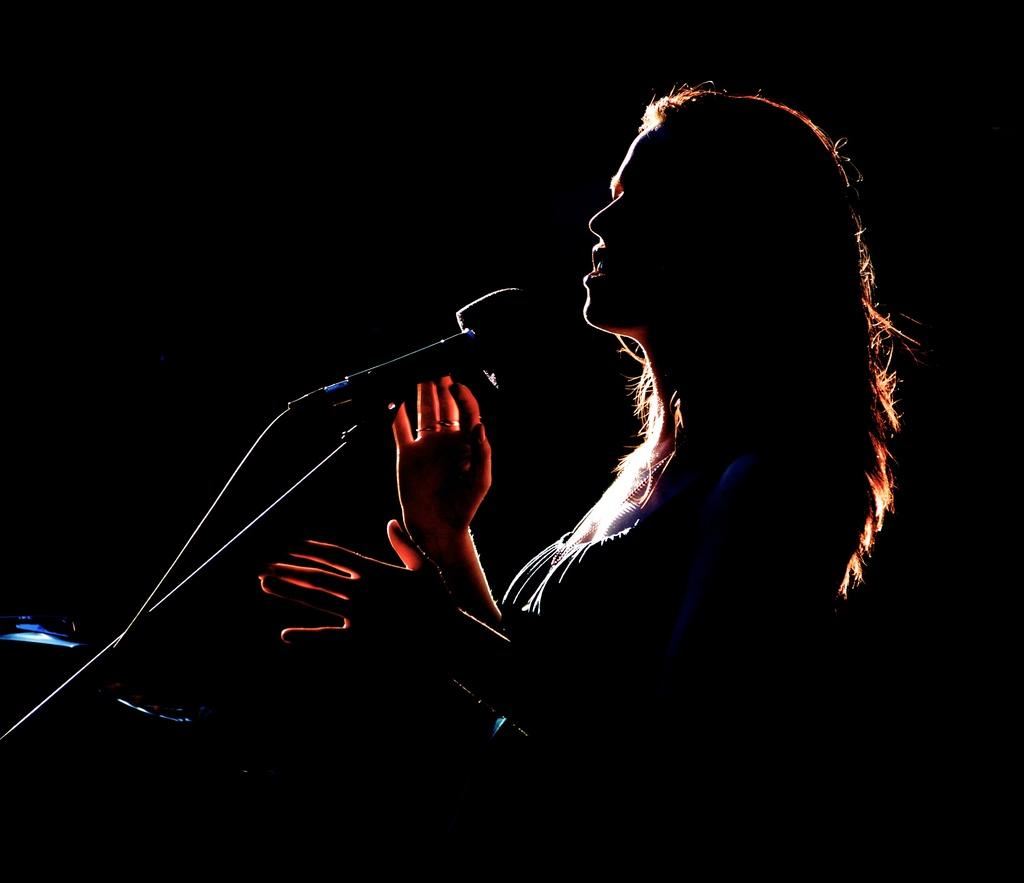Who is the main subject in the image? There is a girl in the image. What is the girl doing in the image? The girl is singing in the image. What object is the girl holding while singing? The girl is holding a microphone in the image. What type of curve can be seen in the image? There is no curve present in the image; it features a girl singing while holding a microphone. 